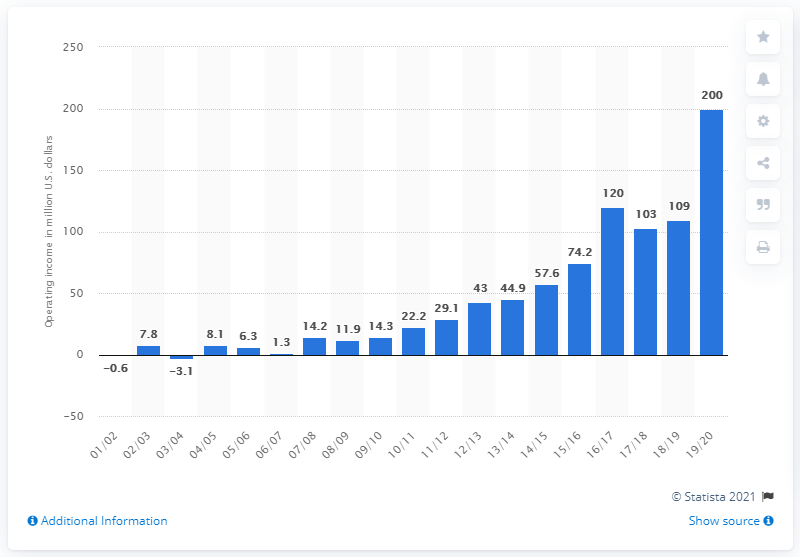Draw attention to some important aspects in this diagram. The operating income of the Golden State Warriors in the 2019/20 season was 200 million dollars. 